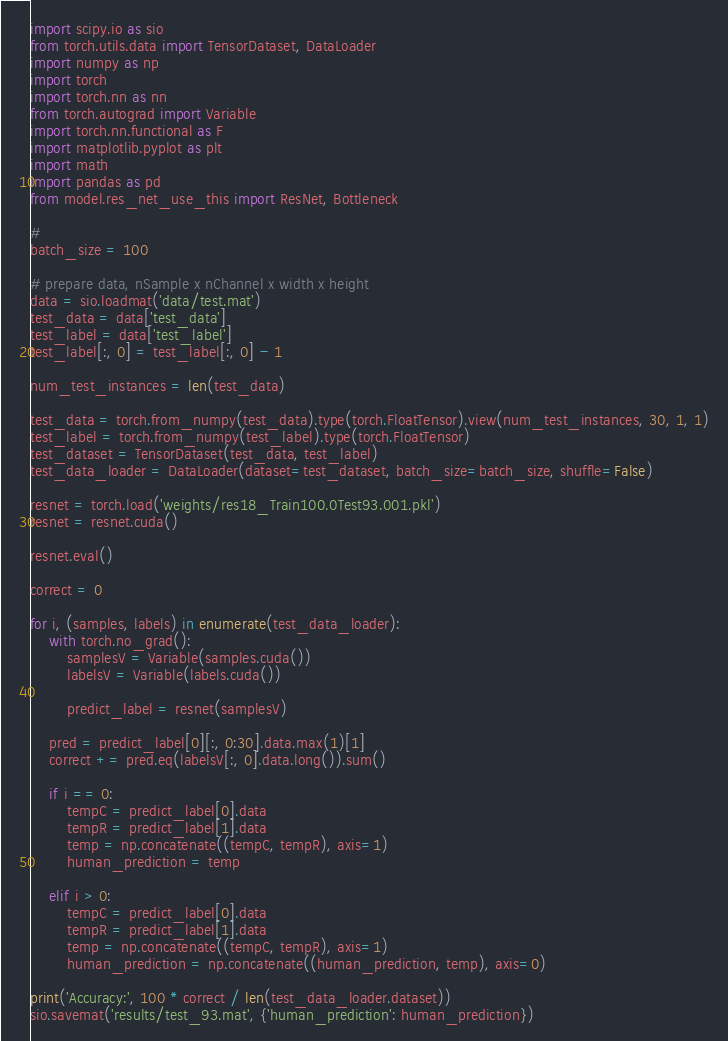Convert code to text. <code><loc_0><loc_0><loc_500><loc_500><_Python_>import scipy.io as sio
from torch.utils.data import TensorDataset, DataLoader
import numpy as np
import torch
import torch.nn as nn
from torch.autograd import Variable
import torch.nn.functional as F
import matplotlib.pyplot as plt
import math
import pandas as pd
from model.res_net_use_this import ResNet, Bottleneck

#
batch_size = 100

# prepare data, nSample x nChannel x width x height
data = sio.loadmat('data/test.mat')
test_data = data['test_data']
test_label = data['test_label']
test_label[:, 0] = test_label[:, 0] - 1

num_test_instances = len(test_data)

test_data = torch.from_numpy(test_data).type(torch.FloatTensor).view(num_test_instances, 30, 1, 1)
test_label = torch.from_numpy(test_label).type(torch.FloatTensor)
test_dataset = TensorDataset(test_data, test_label)
test_data_loader = DataLoader(dataset=test_dataset, batch_size=batch_size, shuffle=False)

resnet = torch.load('weights/res18_Train100.0Test93.001.pkl')
resnet = resnet.cuda()

resnet.eval()

correct = 0

for i, (samples, labels) in enumerate(test_data_loader):
    with torch.no_grad():
        samplesV = Variable(samples.cuda())
        labelsV = Variable(labels.cuda())

        predict_label = resnet(samplesV)

    pred = predict_label[0][:, 0:30].data.max(1)[1]
    correct += pred.eq(labelsV[:, 0].data.long()).sum()

    if i == 0:
        tempC = predict_label[0].data
        tempR = predict_label[1].data
        temp = np.concatenate((tempC, tempR), axis=1)
        human_prediction = temp

    elif i > 0:
        tempC = predict_label[0].data
        tempR = predict_label[1].data
        temp = np.concatenate((tempC, tempR), axis=1)
        human_prediction = np.concatenate((human_prediction, temp), axis=0)

print('Accuracy:', 100 * correct / len(test_data_loader.dataset))
sio.savemat('results/test_93.mat', {'human_prediction': human_prediction})

</code> 